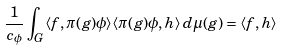<formula> <loc_0><loc_0><loc_500><loc_500>\frac { 1 } { c _ { \phi } } \int _ { G } \langle f , \pi ( g ) \phi \rangle \langle \pi ( g ) \phi , h \rangle \, d \mu ( g ) = \langle f , h \rangle</formula> 